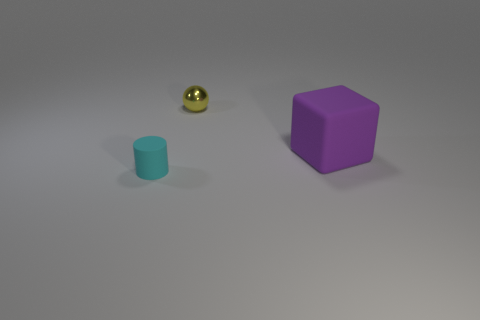Add 1 large purple blocks. How many objects exist? 4 Subtract all cylinders. How many objects are left? 2 Subtract all big brown cylinders. Subtract all shiny balls. How many objects are left? 2 Add 2 yellow metallic spheres. How many yellow metallic spheres are left? 3 Add 2 purple matte blocks. How many purple matte blocks exist? 3 Subtract 0 blue spheres. How many objects are left? 3 